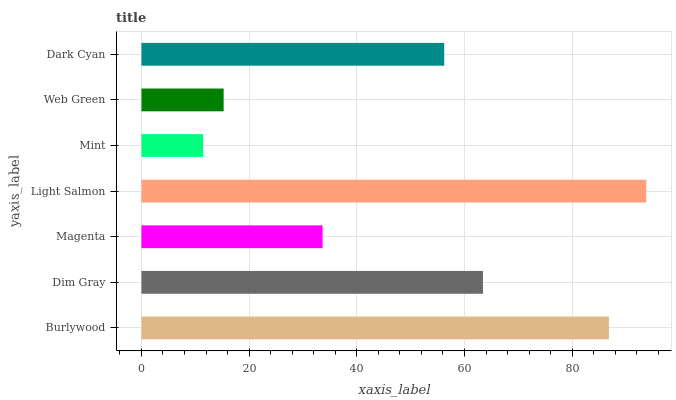Is Mint the minimum?
Answer yes or no. Yes. Is Light Salmon the maximum?
Answer yes or no. Yes. Is Dim Gray the minimum?
Answer yes or no. No. Is Dim Gray the maximum?
Answer yes or no. No. Is Burlywood greater than Dim Gray?
Answer yes or no. Yes. Is Dim Gray less than Burlywood?
Answer yes or no. Yes. Is Dim Gray greater than Burlywood?
Answer yes or no. No. Is Burlywood less than Dim Gray?
Answer yes or no. No. Is Dark Cyan the high median?
Answer yes or no. Yes. Is Dark Cyan the low median?
Answer yes or no. Yes. Is Web Green the high median?
Answer yes or no. No. Is Light Salmon the low median?
Answer yes or no. No. 